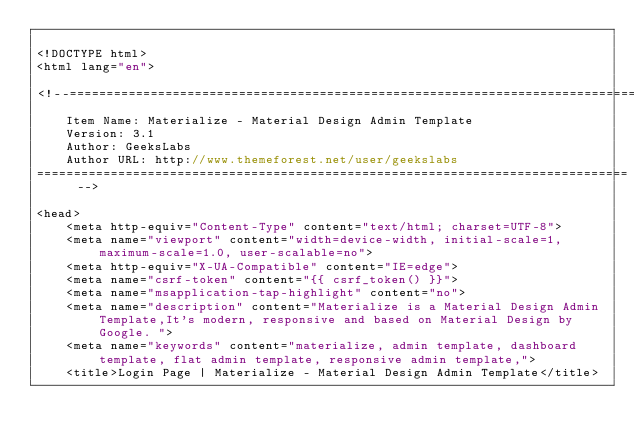Convert code to text. <code><loc_0><loc_0><loc_500><loc_500><_PHP_>
<!DOCTYPE html>
<html lang="en">

<!--================================================================================
	Item Name: Materialize - Material Design Admin Template
	Version: 3.1
	Author: GeeksLabs
	Author URL: http://www.themeforest.net/user/geekslabs
================================================================================ -->

<head>
    <meta http-equiv="Content-Type" content="text/html; charset=UTF-8">
    <meta name="viewport" content="width=device-width, initial-scale=1, maximum-scale=1.0, user-scalable=no">
    <meta http-equiv="X-UA-Compatible" content="IE=edge">
    <meta name="csrf-token" content="{{ csrf_token() }}">
    <meta name="msapplication-tap-highlight" content="no">
    <meta name="description" content="Materialize is a Material Design Admin Template,It's modern, responsive and based on Material Design by Google. ">
    <meta name="keywords" content="materialize, admin template, dashboard template, flat admin template, responsive admin template,">
    <title>Login Page | Materialize - Material Design Admin Template</title>
</code> 